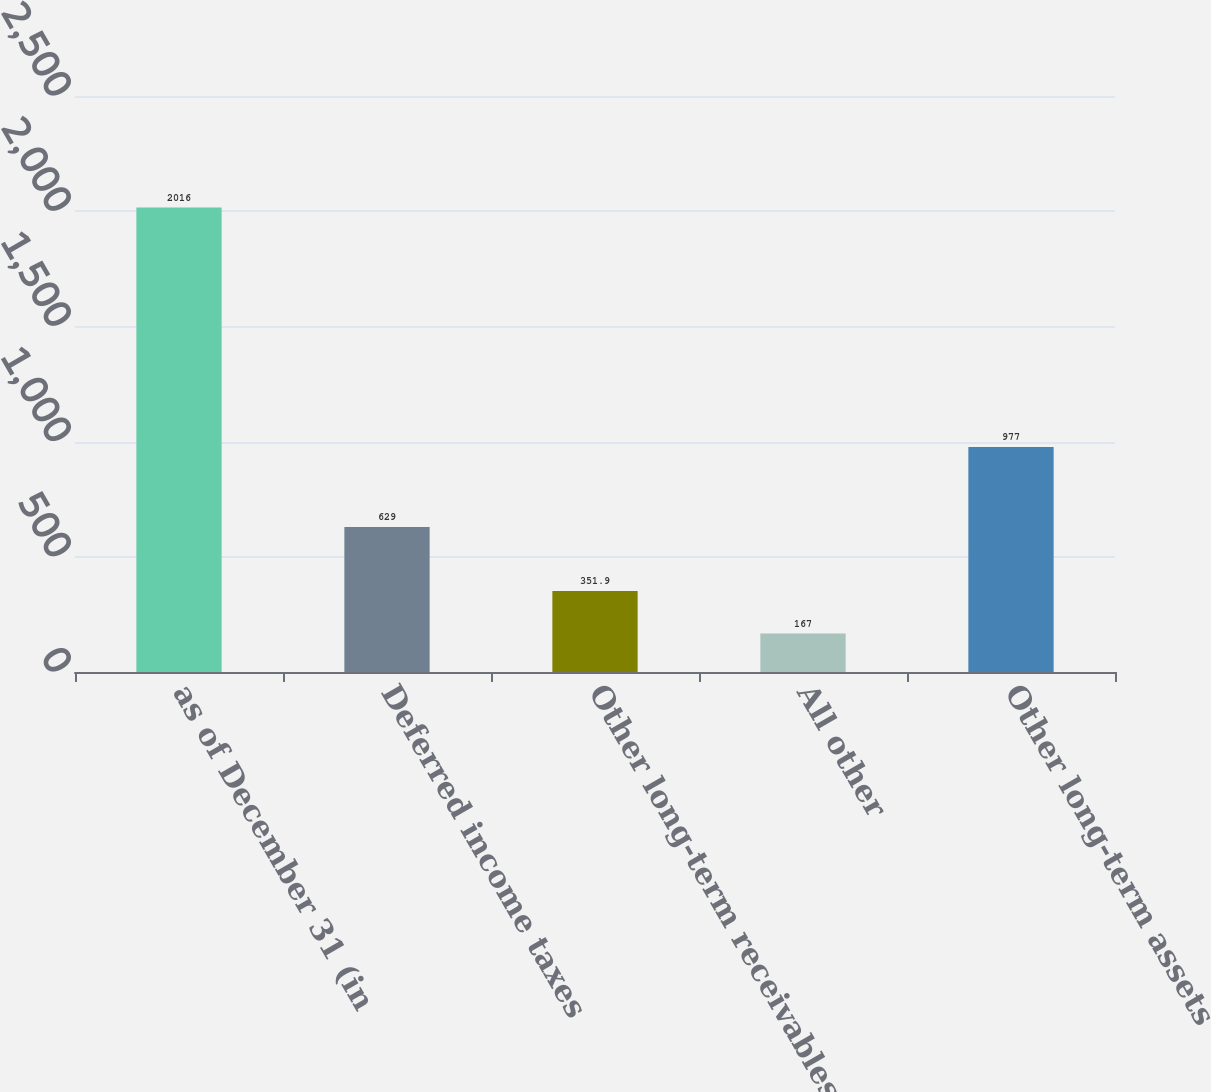<chart> <loc_0><loc_0><loc_500><loc_500><bar_chart><fcel>as of December 31 (in<fcel>Deferred income taxes<fcel>Other long-term receivables<fcel>All other<fcel>Other long-term assets<nl><fcel>2016<fcel>629<fcel>351.9<fcel>167<fcel>977<nl></chart> 